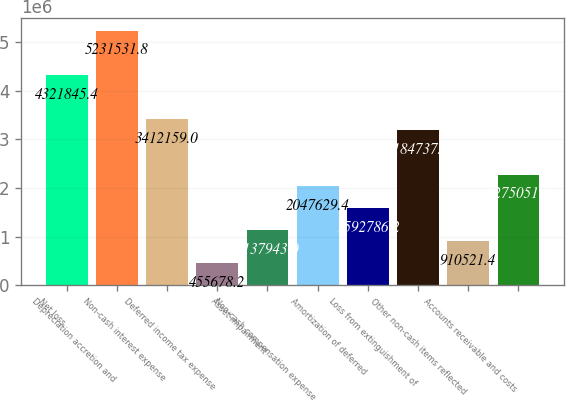Convert chart to OTSL. <chart><loc_0><loc_0><loc_500><loc_500><bar_chart><fcel>Net loss<fcel>Depreciation accretion and<fcel>Non-cash interest expense<fcel>Deferred income tax expense<fcel>Asset impairment<fcel>Non-cash compensation expense<fcel>Amortization of deferred<fcel>Loss from extinguishment of<fcel>Other non-cash items reflected<fcel>Accounts receivable and costs<nl><fcel>4.32185e+06<fcel>5.23153e+06<fcel>3.41216e+06<fcel>455678<fcel>1.13794e+06<fcel>2.04763e+06<fcel>1.59279e+06<fcel>3.18474e+06<fcel>910521<fcel>2.27505e+06<nl></chart> 